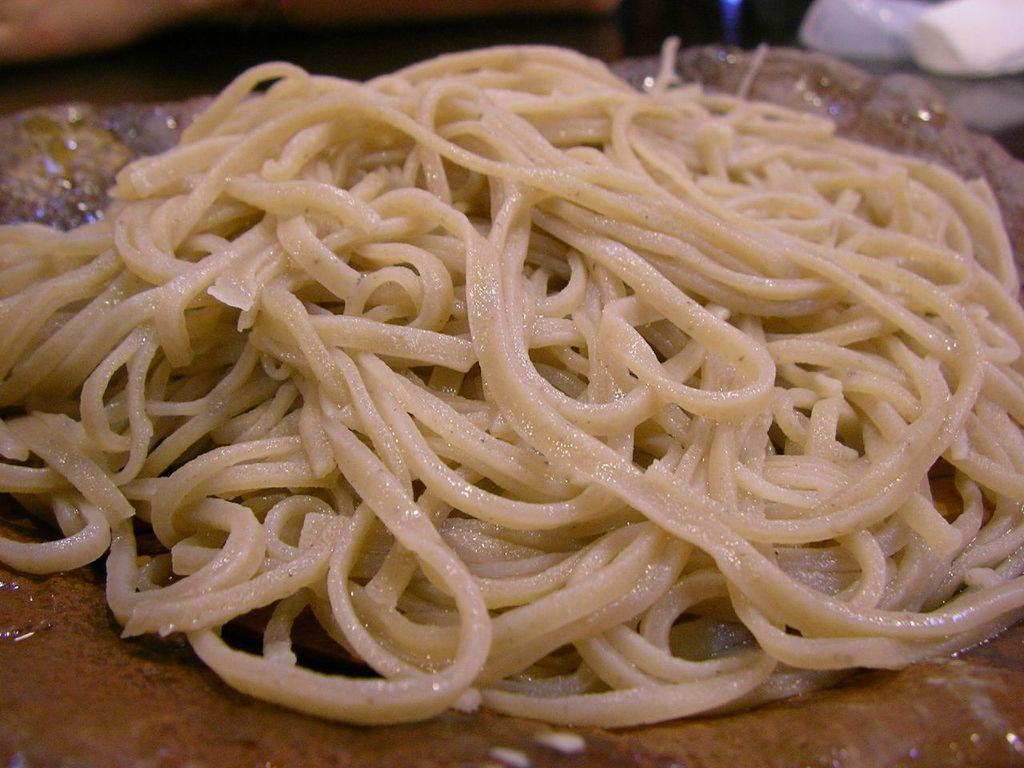In one or two sentences, can you explain what this image depicts? In this picture, we see the noodles. At the bottom, it is brown in color. At the top, it is black in color. In the right top, we see an object in white color. 